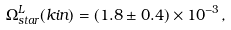<formula> <loc_0><loc_0><loc_500><loc_500>\Omega _ { s t a r } ^ { L } ( k i n ) = ( 1 . 8 \pm 0 . 4 ) \times 1 0 ^ { - 3 } ,</formula> 